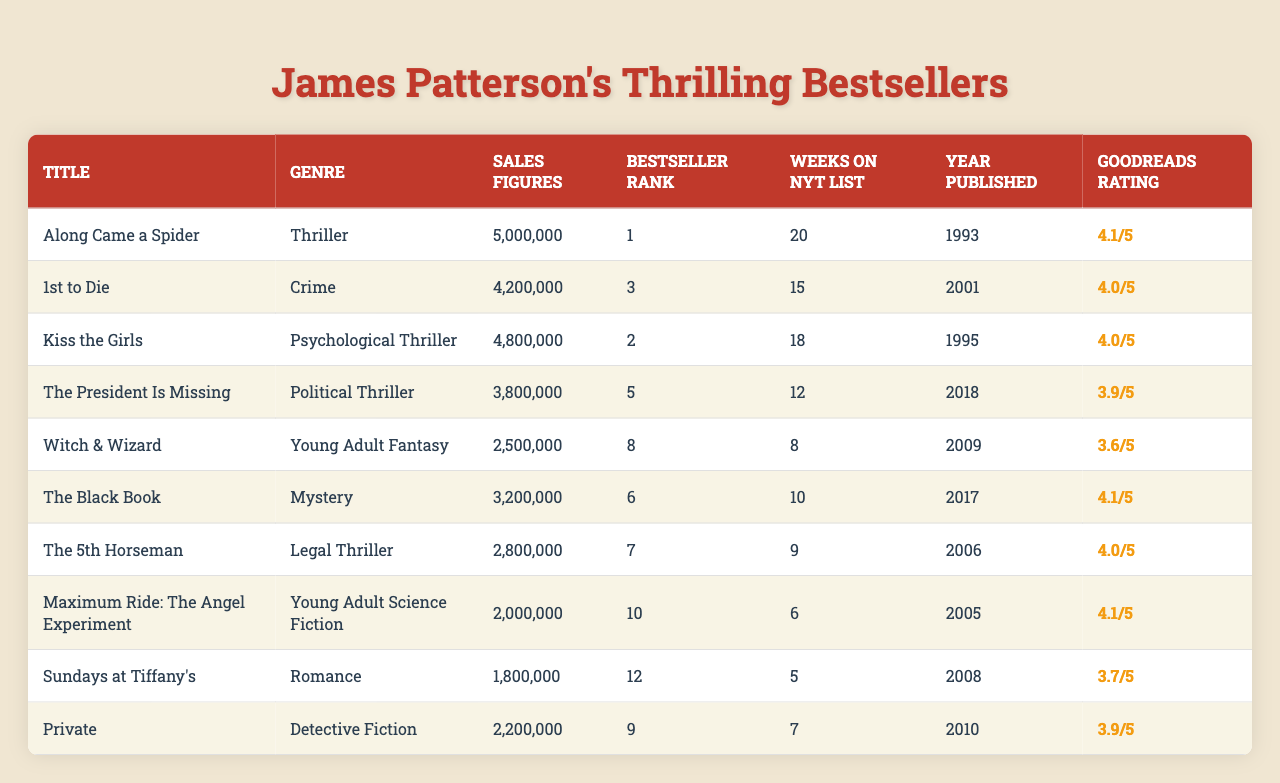What is the bestselling James Patterson novel? The bestselling novel based on the table is "Along Came a Spider," which has a bestseller rank of 1.
Answer: Along Came a Spider Which genre has the highest total sales figures? The total sales figures for the Thriller genre (5,000,000) are the highest compared to other genres listed.
Answer: Thriller How many weeks did "Kiss the Girls" stay on the New York Times list? "Kiss the Girls" stayed on the New York Times list for 18 weeks, as shown in its respective row in the table.
Answer: 18 weeks What is the difference in sales figures between "1st to Die" and "The President Is Missing"? "1st to Die" has sales figures of 4,200,000 and "The President Is Missing" has sales figures of 3,800,000. The difference is 4,200,000 - 3,800,000 = 400,000.
Answer: 400,000 Are there any novels with a Goodreads rating above 4.0? Yes, both "Along Came a Spider" and "Kiss the Girls" have Goodreads ratings above 4.0, as indicated in the ratings column.
Answer: Yes What is the average Goodreads rating of all the novels listed? The average is calculated by summing the ratings (4.1 + 4.0 + 4.0 + 3.9 + 3.6 + 4.1 + 4.0 + 4.1 + 3.7 + 3.9 = 39.4) and dividing by the number of novels (10), so the average is 39.4 / 10 = 3.94.
Answer: 3.94 Which novel was published the earliest? "Along Came a Spider," published in 1993, is the earliest novel according to the publication years in the table.
Answer: Along Came a Spider How many novels in the dataset are classified as Young Adult? There are 2 novels in the Young Adult category: "Witch & Wizard" and "Maximum Ride: The Angel Experiment."
Answer: 2 Is "Sundays at Tiffany's" among the top 10 bestsellers? No, "Sundays at Tiffany's," with a rank of 12, is not within the top 10 bestsellers based on the bestseller rank in the table.
Answer: No What is the total sales figure for all the novels in the table? The total sales figures are calculated by summing all the sales figures listed, which results in 5,000,000 + 4,200,000 + 4,800,000 + 3,800,000 + 2,500,000 + 3,200,000 + 2,800,000 + 2,000,000 + 1,800,000 + 2,200,000 = 32,300,000.
Answer: 32,300,000 